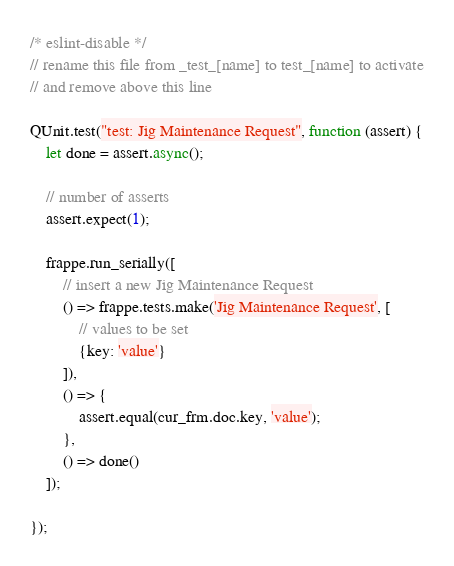Convert code to text. <code><loc_0><loc_0><loc_500><loc_500><_JavaScript_>/* eslint-disable */
// rename this file from _test_[name] to test_[name] to activate
// and remove above this line

QUnit.test("test: Jig Maintenance Request", function (assert) {
	let done = assert.async();

	// number of asserts
	assert.expect(1);

	frappe.run_serially([
		// insert a new Jig Maintenance Request
		() => frappe.tests.make('Jig Maintenance Request', [
			// values to be set
			{key: 'value'}
		]),
		() => {
			assert.equal(cur_frm.doc.key, 'value');
		},
		() => done()
	]);

});
</code> 